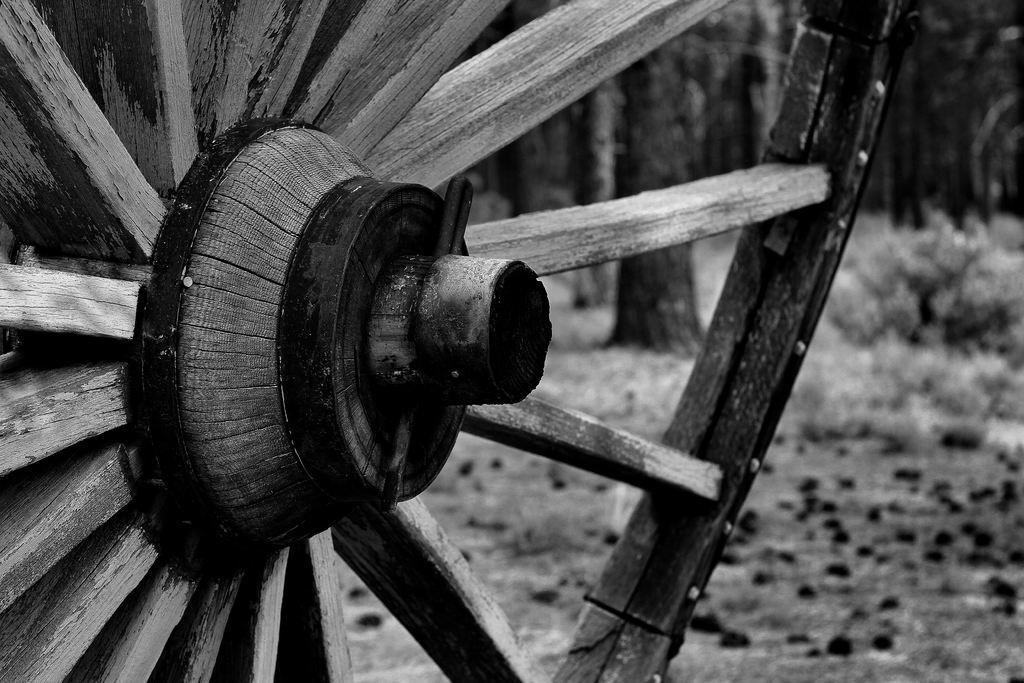What object is on the ground in the image? There is a wheel on the ground in the image. What can be seen in the background of the image? There are tree trunks in the background of the image. What type of border is depicted in the image? There is no border depicted in the image; it features a wheel on the ground and tree trunks in the background. What religious symbol can be seen in the image? There is no religious symbol present in the image. 